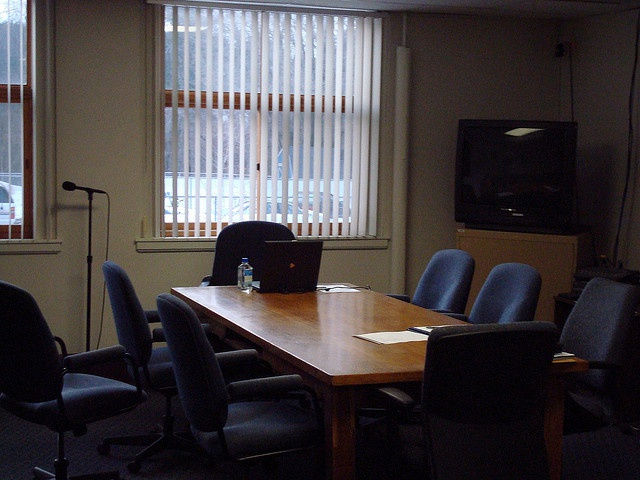Describe the objects in this image and their specific colors. I can see chair in snow, black, and gray tones, dining table in white, darkgray, gray, brown, and lightgray tones, chair in snow, black, and gray tones, tv in snow, black, and gray tones, and chair in white, black, darkblue, and gray tones in this image. 